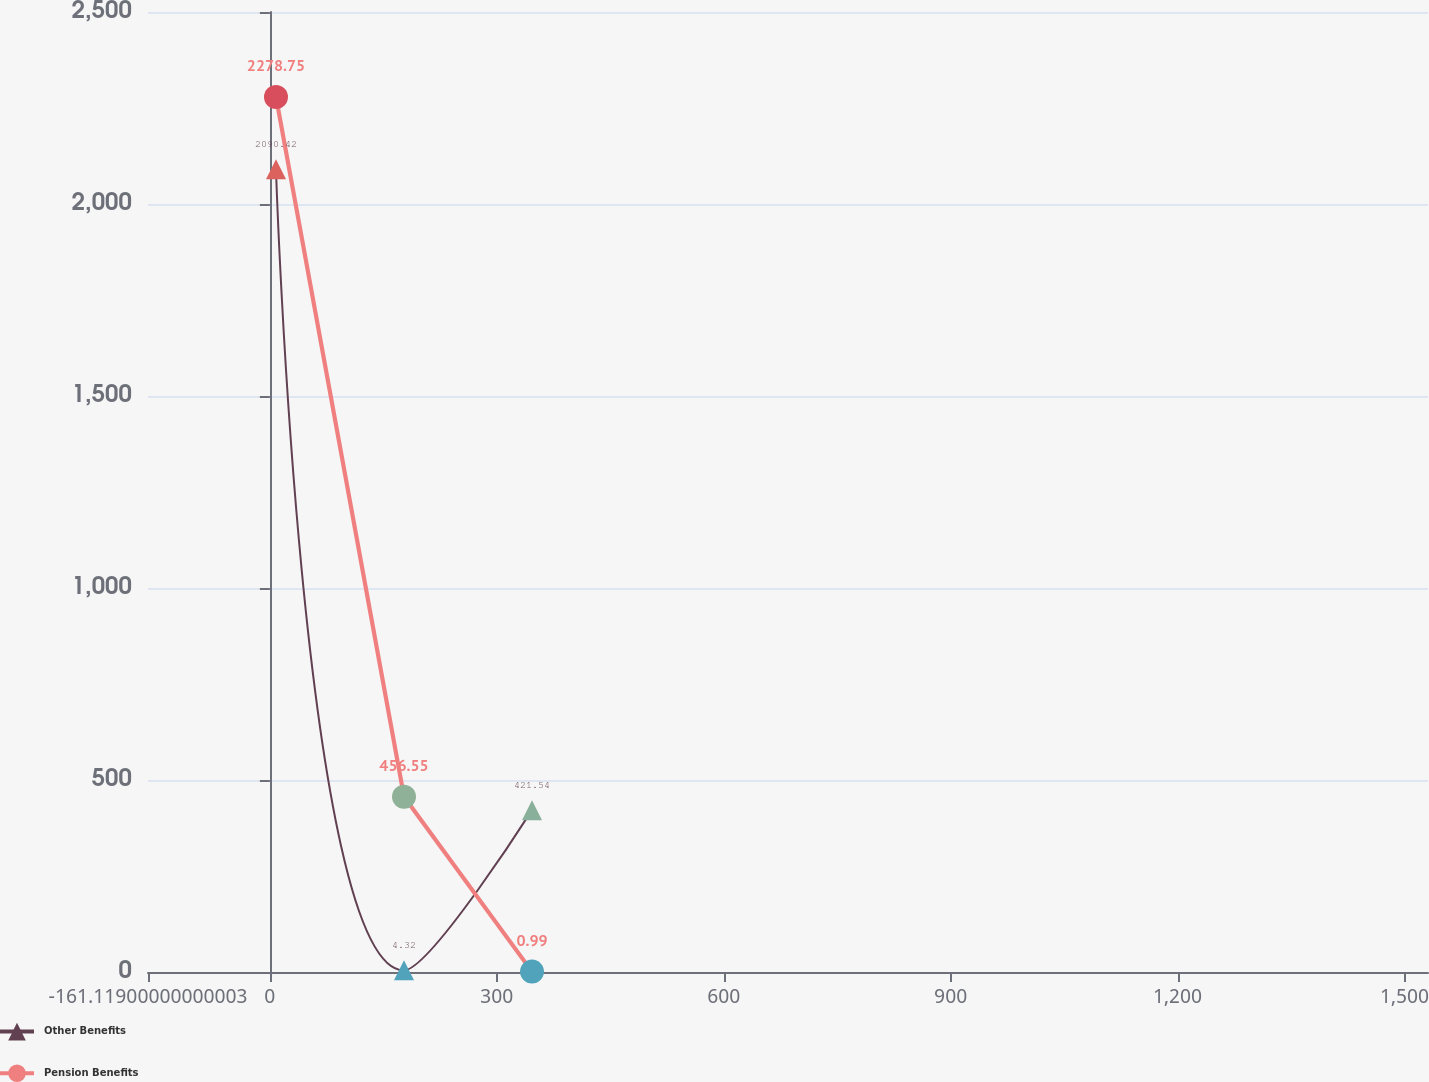Convert chart to OTSL. <chart><loc_0><loc_0><loc_500><loc_500><line_chart><ecel><fcel>Other Benefits<fcel>Pension Benefits<nl><fcel>8.1<fcel>2090.42<fcel>2278.75<nl><fcel>177.32<fcel>4.32<fcel>456.55<nl><fcel>346.54<fcel>421.54<fcel>0.99<nl><fcel>1700.29<fcel>212.93<fcel>228.77<nl></chart> 